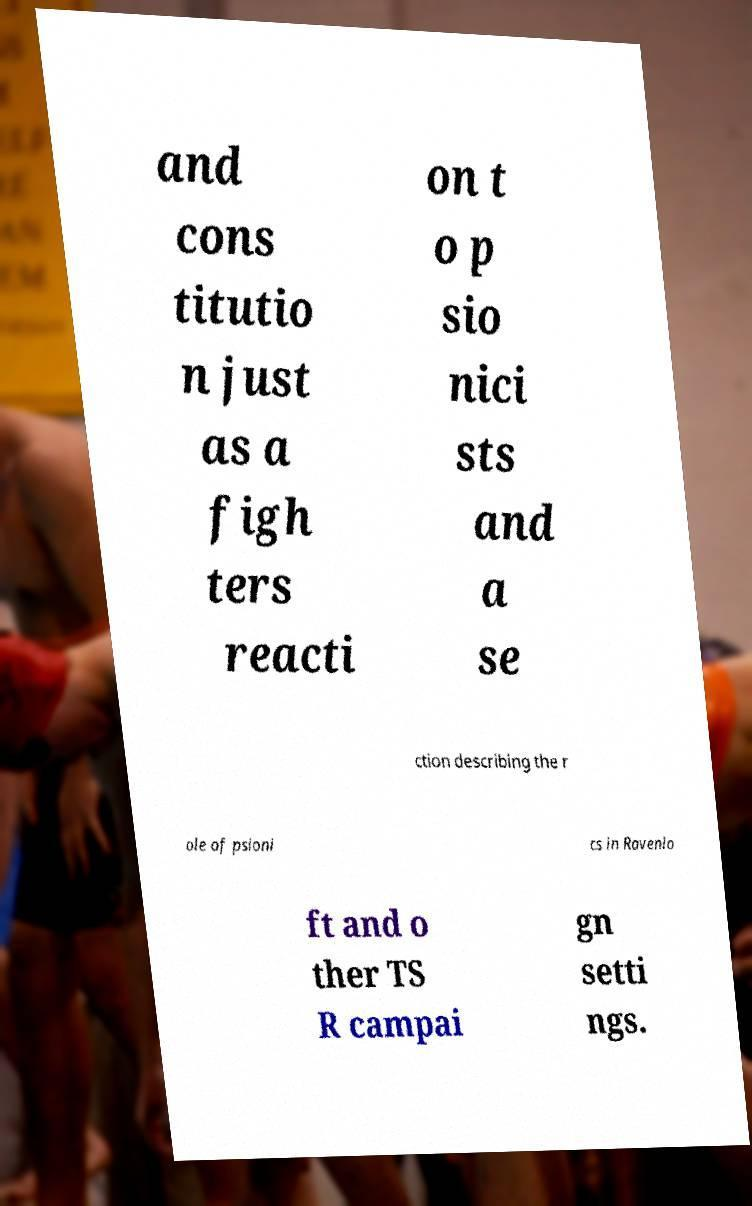Can you read and provide the text displayed in the image?This photo seems to have some interesting text. Can you extract and type it out for me? and cons titutio n just as a figh ters reacti on t o p sio nici sts and a se ction describing the r ole of psioni cs in Ravenlo ft and o ther TS R campai gn setti ngs. 